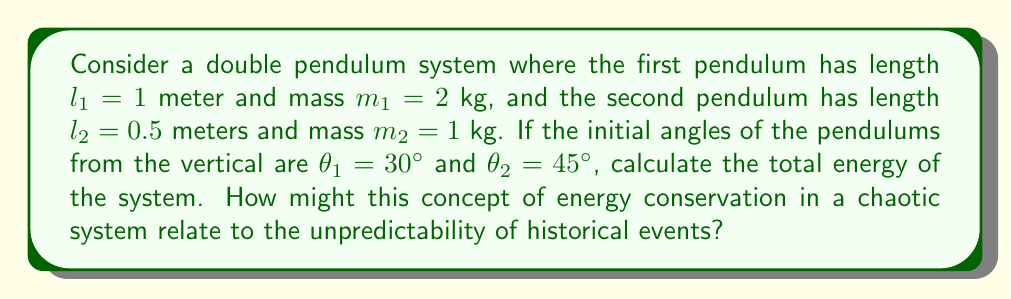Provide a solution to this math problem. Let's approach this step-by-step:

1) The total energy of a double pendulum system is the sum of potential and kinetic energies:

   $E_{total} = E_{potential} + E_{kinetic}$

2) Initially, the system only has potential energy as it starts from rest. The potential energy is given by:

   $E_{potential} = -m_1gl_1\cos(\theta_1) - m_2g(l_1\cos(\theta_1) + l_2\cos(\theta_2))$

   Where $g = 9.8$ m/s² is the acceleration due to gravity.

3) Let's substitute our values:

   $E_{potential} = -(2)(9.8)(1)\cos(30°) - (1)(9.8)(1\cos(30°) + 0.5\cos(45°))$

4) Simplify:
   $\cos(30°) = \frac{\sqrt{3}}{2} \approx 0.866$
   $\cos(45°) = \frac{\sqrt{2}}{2} \approx 0.707$

   $E_{potential} = -19.6(0.866) - 9.8(0.866 + 0.5(0.707))$
                  $= -16.97 - 9.8(0.866 + 0.3535)$
                  $= -16.97 - 11.95$
                  $= -28.92$ J

5) The total energy is equal to this potential energy, as there's no initial kinetic energy.

   $E_{total} = -28.92$ J

This calculation demonstrates energy conservation in a chaotic system. While we can precisely calculate the initial energy, the chaotic nature of the double pendulum means we cannot accurately predict its future states over extended periods, much like how initial conditions in history can lead to unpredictable outcomes over time.
Answer: -28.92 J 